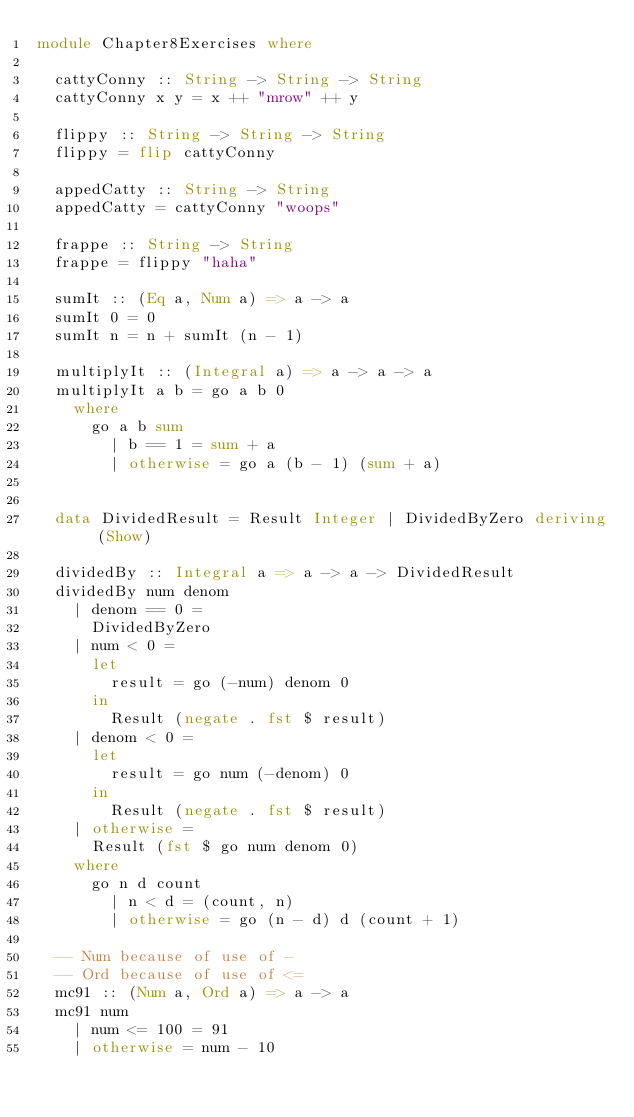Convert code to text. <code><loc_0><loc_0><loc_500><loc_500><_Haskell_>module Chapter8Exercises where

  cattyConny :: String -> String -> String
  cattyConny x y = x ++ "mrow" ++ y

  flippy :: String -> String -> String
  flippy = flip cattyConny

  appedCatty :: String -> String
  appedCatty = cattyConny "woops"

  frappe :: String -> String
  frappe = flippy "haha"

  sumIt :: (Eq a, Num a) => a -> a
  sumIt 0 = 0
  sumIt n = n + sumIt (n - 1)

  multiplyIt :: (Integral a) => a -> a -> a
  multiplyIt a b = go a b 0
    where
      go a b sum
        | b == 1 = sum + a
        | otherwise = go a (b - 1) (sum + a)


  data DividedResult = Result Integer | DividedByZero deriving (Show)

  dividedBy :: Integral a => a -> a -> DividedResult
  dividedBy num denom
    | denom == 0 =
      DividedByZero
    | num < 0 =
      let
        result = go (-num) denom 0
      in
        Result (negate . fst $ result)
    | denom < 0 =
      let
        result = go num (-denom) 0
      in
        Result (negate . fst $ result)
    | otherwise =
      Result (fst $ go num denom 0)
    where
      go n d count
        | n < d = (count, n)
        | otherwise = go (n - d) d (count + 1)

  -- Num because of use of -
  -- Ord because of use of <=
  mc91 :: (Num a, Ord a) => a -> a
  mc91 num
    | num <= 100 = 91
    | otherwise = num - 10
</code> 